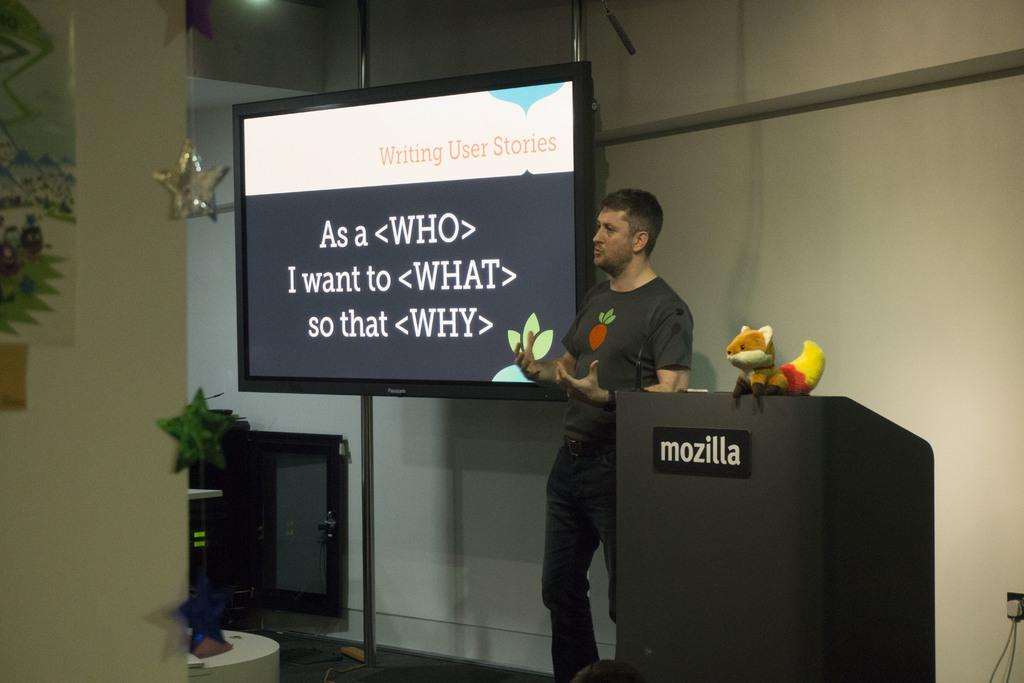What is the main subject of the image? There is a person standing in the image. What object is present near the person? There is a podium in the image. What is on top of the podium? There is a toy on the podium. What can be seen on the screen in the image? There are objects visible in the image. What is the color of the background in the image? The background of the image is white. Can you tell me how many parcels are being delivered by the parent in the image? There is no parent or parcel present in the image. What type of afterthought is being expressed by the person in the image? There is no indication of an afterthought being expressed by the person in the image. 